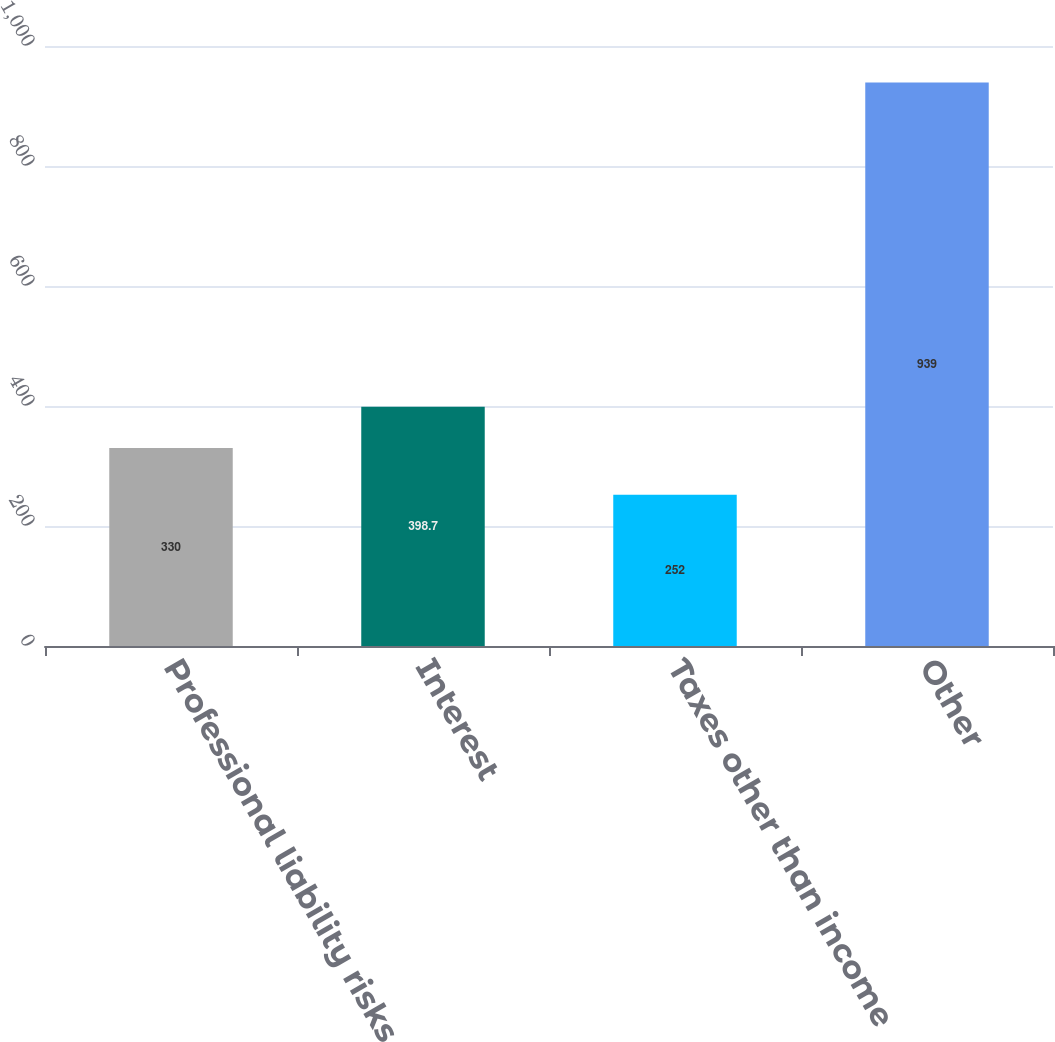Convert chart to OTSL. <chart><loc_0><loc_0><loc_500><loc_500><bar_chart><fcel>Professional liability risks<fcel>Interest<fcel>Taxes other than income<fcel>Other<nl><fcel>330<fcel>398.7<fcel>252<fcel>939<nl></chart> 